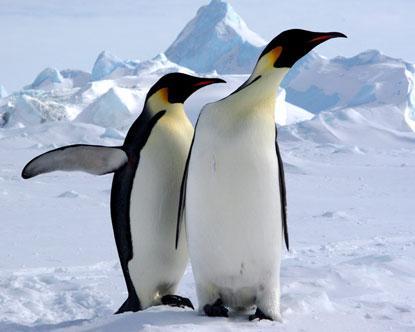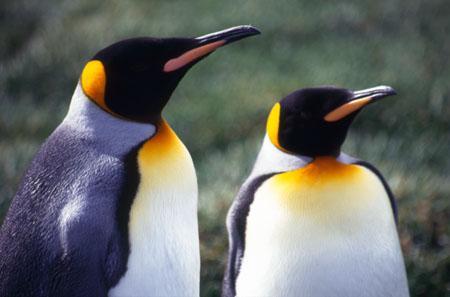The first image is the image on the left, the second image is the image on the right. Examine the images to the left and right. Is the description "There are only two penguins in at least one of the images." accurate? Answer yes or no. Yes. The first image is the image on the left, the second image is the image on the right. For the images displayed, is the sentence "Two penguins stand near each other in the picture on the left." factually correct? Answer yes or no. Yes. The first image is the image on the left, the second image is the image on the right. Considering the images on both sides, is "An image features two penguins standing close together." valid? Answer yes or no. Yes. The first image is the image on the left, the second image is the image on the right. Evaluate the accuracy of this statement regarding the images: "There are two penguins in the left image.". Is it true? Answer yes or no. Yes. The first image is the image on the left, the second image is the image on the right. For the images shown, is this caption "An image contains just two penguins." true? Answer yes or no. Yes. 